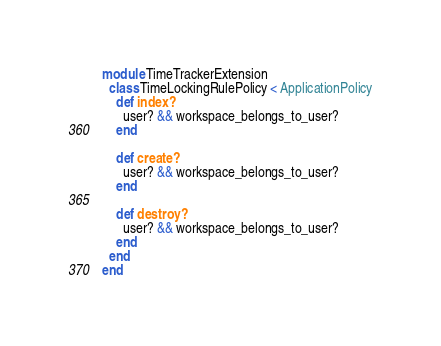Convert code to text. <code><loc_0><loc_0><loc_500><loc_500><_Ruby_>module TimeTrackerExtension
  class TimeLockingRulePolicy < ApplicationPolicy
    def index?
      user? && workspace_belongs_to_user?
    end

    def create?
      user? && workspace_belongs_to_user?
    end

    def destroy?
      user? && workspace_belongs_to_user?
    end
  end
end
</code> 